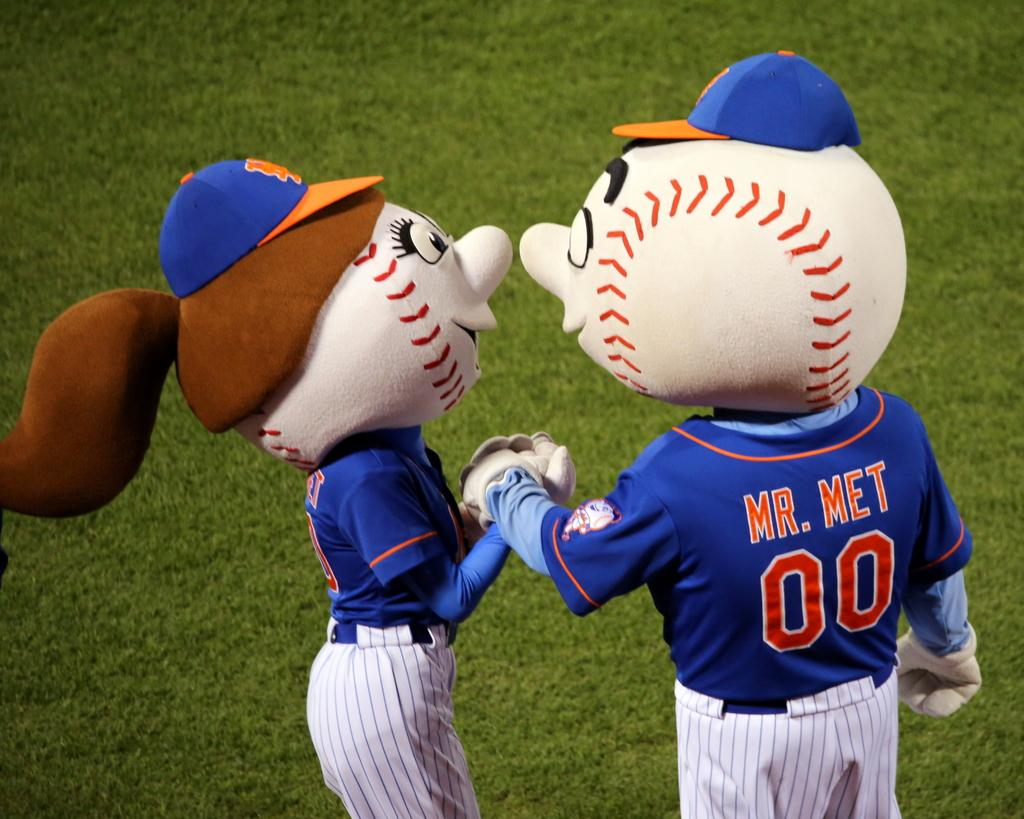<image>
Relay a brief, clear account of the picture shown. A few man and woman baseball mascots are holding hands, he has MR MET 00 on his shirt in back. 